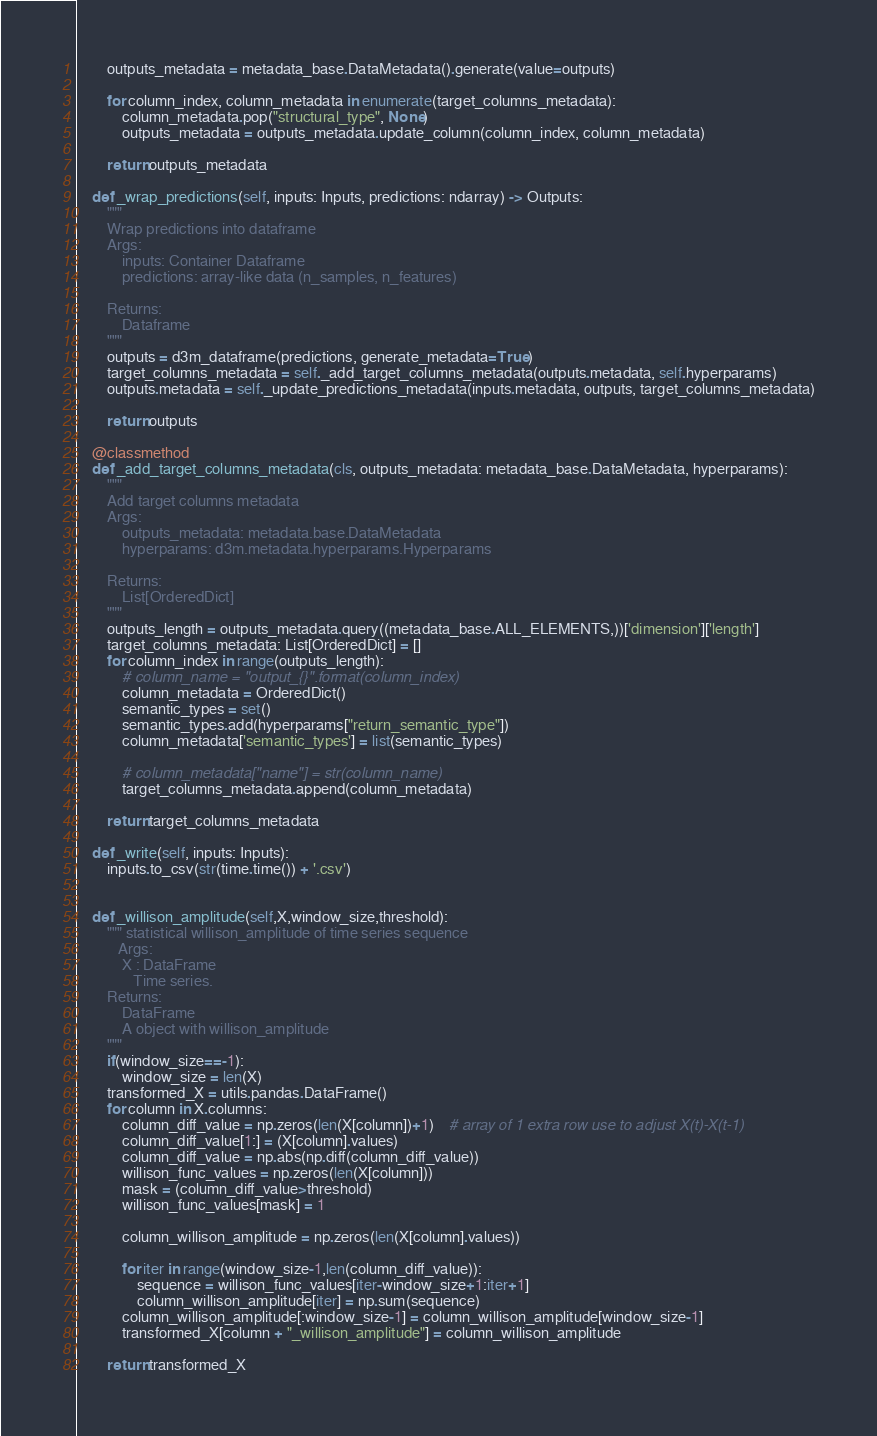Convert code to text. <code><loc_0><loc_0><loc_500><loc_500><_Python_>        outputs_metadata = metadata_base.DataMetadata().generate(value=outputs)

        for column_index, column_metadata in enumerate(target_columns_metadata):
            column_metadata.pop("structural_type", None)
            outputs_metadata = outputs_metadata.update_column(column_index, column_metadata)

        return outputs_metadata

    def _wrap_predictions(self, inputs: Inputs, predictions: ndarray) -> Outputs:
        """
        Wrap predictions into dataframe
        Args:
            inputs: Container Dataframe
            predictions: array-like data (n_samples, n_features)

        Returns:
            Dataframe
        """
        outputs = d3m_dataframe(predictions, generate_metadata=True)
        target_columns_metadata = self._add_target_columns_metadata(outputs.metadata, self.hyperparams)
        outputs.metadata = self._update_predictions_metadata(inputs.metadata, outputs, target_columns_metadata)

        return outputs

    @classmethod
    def _add_target_columns_metadata(cls, outputs_metadata: metadata_base.DataMetadata, hyperparams):
        """
        Add target columns metadata
        Args:
            outputs_metadata: metadata.base.DataMetadata
            hyperparams: d3m.metadata.hyperparams.Hyperparams

        Returns:
            List[OrderedDict]
        """
        outputs_length = outputs_metadata.query((metadata_base.ALL_ELEMENTS,))['dimension']['length']
        target_columns_metadata: List[OrderedDict] = []
        for column_index in range(outputs_length):
            # column_name = "output_{}".format(column_index)
            column_metadata = OrderedDict()
            semantic_types = set()
            semantic_types.add(hyperparams["return_semantic_type"])
            column_metadata['semantic_types'] = list(semantic_types)

            # column_metadata["name"] = str(column_name)
            target_columns_metadata.append(column_metadata)

        return target_columns_metadata

    def _write(self, inputs: Inputs):
        inputs.to_csv(str(time.time()) + '.csv')


    def _willison_amplitude(self,X,window_size,threshold):
        """ statistical willison_amplitude of time series sequence
           Args:
            X : DataFrame
               Time series.
        Returns:
            DataFrame
            A object with willison_amplitude
        """
        if(window_size==-1):
            window_size = len(X)
        transformed_X = utils.pandas.DataFrame()
        for column in X.columns:
            column_diff_value = np.zeros(len(X[column])+1)    # array of 1 extra row use to adjust X(t)-X(t-1)
            column_diff_value[1:] = (X[column].values)
            column_diff_value = np.abs(np.diff(column_diff_value))
            willison_func_values = np.zeros(len(X[column]))
            mask = (column_diff_value>threshold)
            willison_func_values[mask] = 1

            column_willison_amplitude = np.zeros(len(X[column].values))

            for iter in range(window_size-1,len(column_diff_value)):
                sequence = willison_func_values[iter-window_size+1:iter+1]
                column_willison_amplitude[iter] = np.sum(sequence)
            column_willison_amplitude[:window_size-1] = column_willison_amplitude[window_size-1]
            transformed_X[column + "_willison_amplitude"] = column_willison_amplitude

        return transformed_X
</code> 